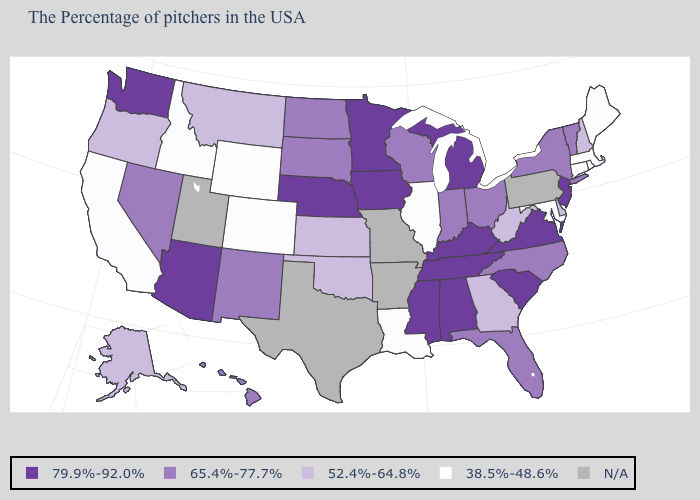What is the value of Ohio?
Be succinct. 65.4%-77.7%. Does Connecticut have the lowest value in the USA?
Give a very brief answer. Yes. Is the legend a continuous bar?
Answer briefly. No. Name the states that have a value in the range N/A?
Write a very short answer. Pennsylvania, Missouri, Arkansas, Texas, Utah. Does the first symbol in the legend represent the smallest category?
Short answer required. No. Name the states that have a value in the range 52.4%-64.8%?
Quick response, please. New Hampshire, Delaware, West Virginia, Georgia, Kansas, Oklahoma, Montana, Oregon, Alaska. What is the lowest value in states that border Oklahoma?
Write a very short answer. 38.5%-48.6%. What is the value of Tennessee?
Short answer required. 79.9%-92.0%. Name the states that have a value in the range 52.4%-64.8%?
Keep it brief. New Hampshire, Delaware, West Virginia, Georgia, Kansas, Oklahoma, Montana, Oregon, Alaska. Does the map have missing data?
Short answer required. Yes. What is the value of Nebraska?
Give a very brief answer. 79.9%-92.0%. Name the states that have a value in the range 38.5%-48.6%?
Keep it brief. Maine, Massachusetts, Rhode Island, Connecticut, Maryland, Illinois, Louisiana, Wyoming, Colorado, Idaho, California. What is the highest value in the USA?
Write a very short answer. 79.9%-92.0%. What is the lowest value in the MidWest?
Be succinct. 38.5%-48.6%. 